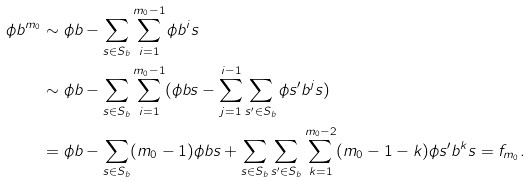Convert formula to latex. <formula><loc_0><loc_0><loc_500><loc_500>\phi b ^ { m _ { 0 } } & \sim \phi b - \sum _ { s \in S _ { b } } \sum _ { i = 1 } ^ { m _ { 0 } - 1 } \phi b ^ { i } s \\ & \sim \phi b - \sum _ { s \in S _ { b } } \sum _ { i = 1 } ^ { m _ { 0 } - 1 } ( \phi b s - \sum _ { j = 1 } ^ { i - 1 } \sum _ { s ^ { \prime } \in S _ { b } } \phi s ^ { \prime } b ^ { j } s ) \\ & = \phi b - \sum _ { s \in S _ { b } } ( m _ { 0 } - 1 ) \phi b s + \sum _ { s \in S _ { b } } \sum _ { s ^ { \prime } \in S _ { b } } \sum _ { k = 1 } ^ { m _ { 0 } - 2 } ( m _ { 0 } - 1 - k ) \phi s ^ { \prime } b ^ { k } s = f _ { m _ { 0 } } .</formula> 